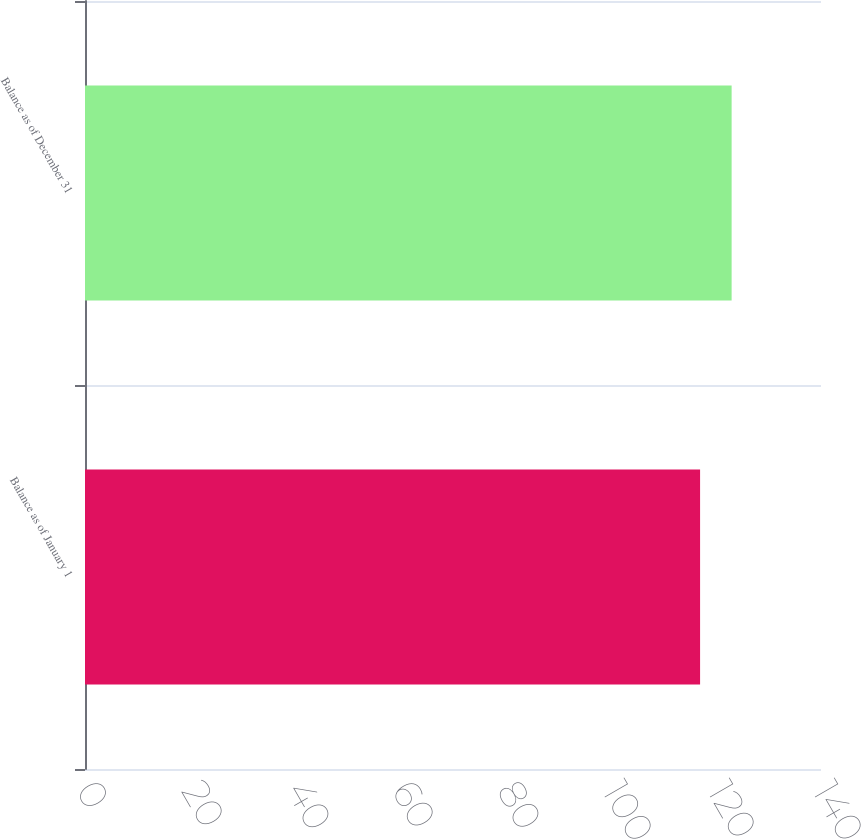<chart> <loc_0><loc_0><loc_500><loc_500><bar_chart><fcel>Balance as of January 1<fcel>Balance as of December 31<nl><fcel>117<fcel>123<nl></chart> 